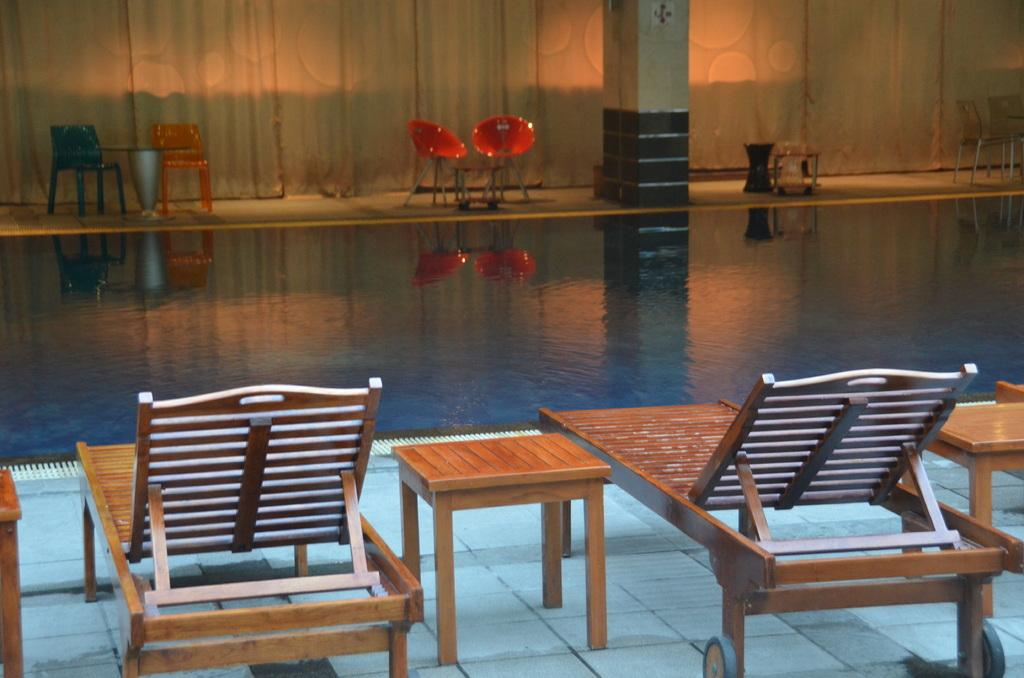What is the main feature of the image? There is a swimming pool in the image. What type of furniture is present in the image? Chairs and tables are visible in the image. Are there any personal belongings or items around the area? Clothes are visible around the area. What type of toys can be seen in the image? There are no toys present in the image. Is there a competition taking place in the swimming pool? There is no indication of a competition in the image; it simply shows a swimming pool with chairs and tables nearby. 